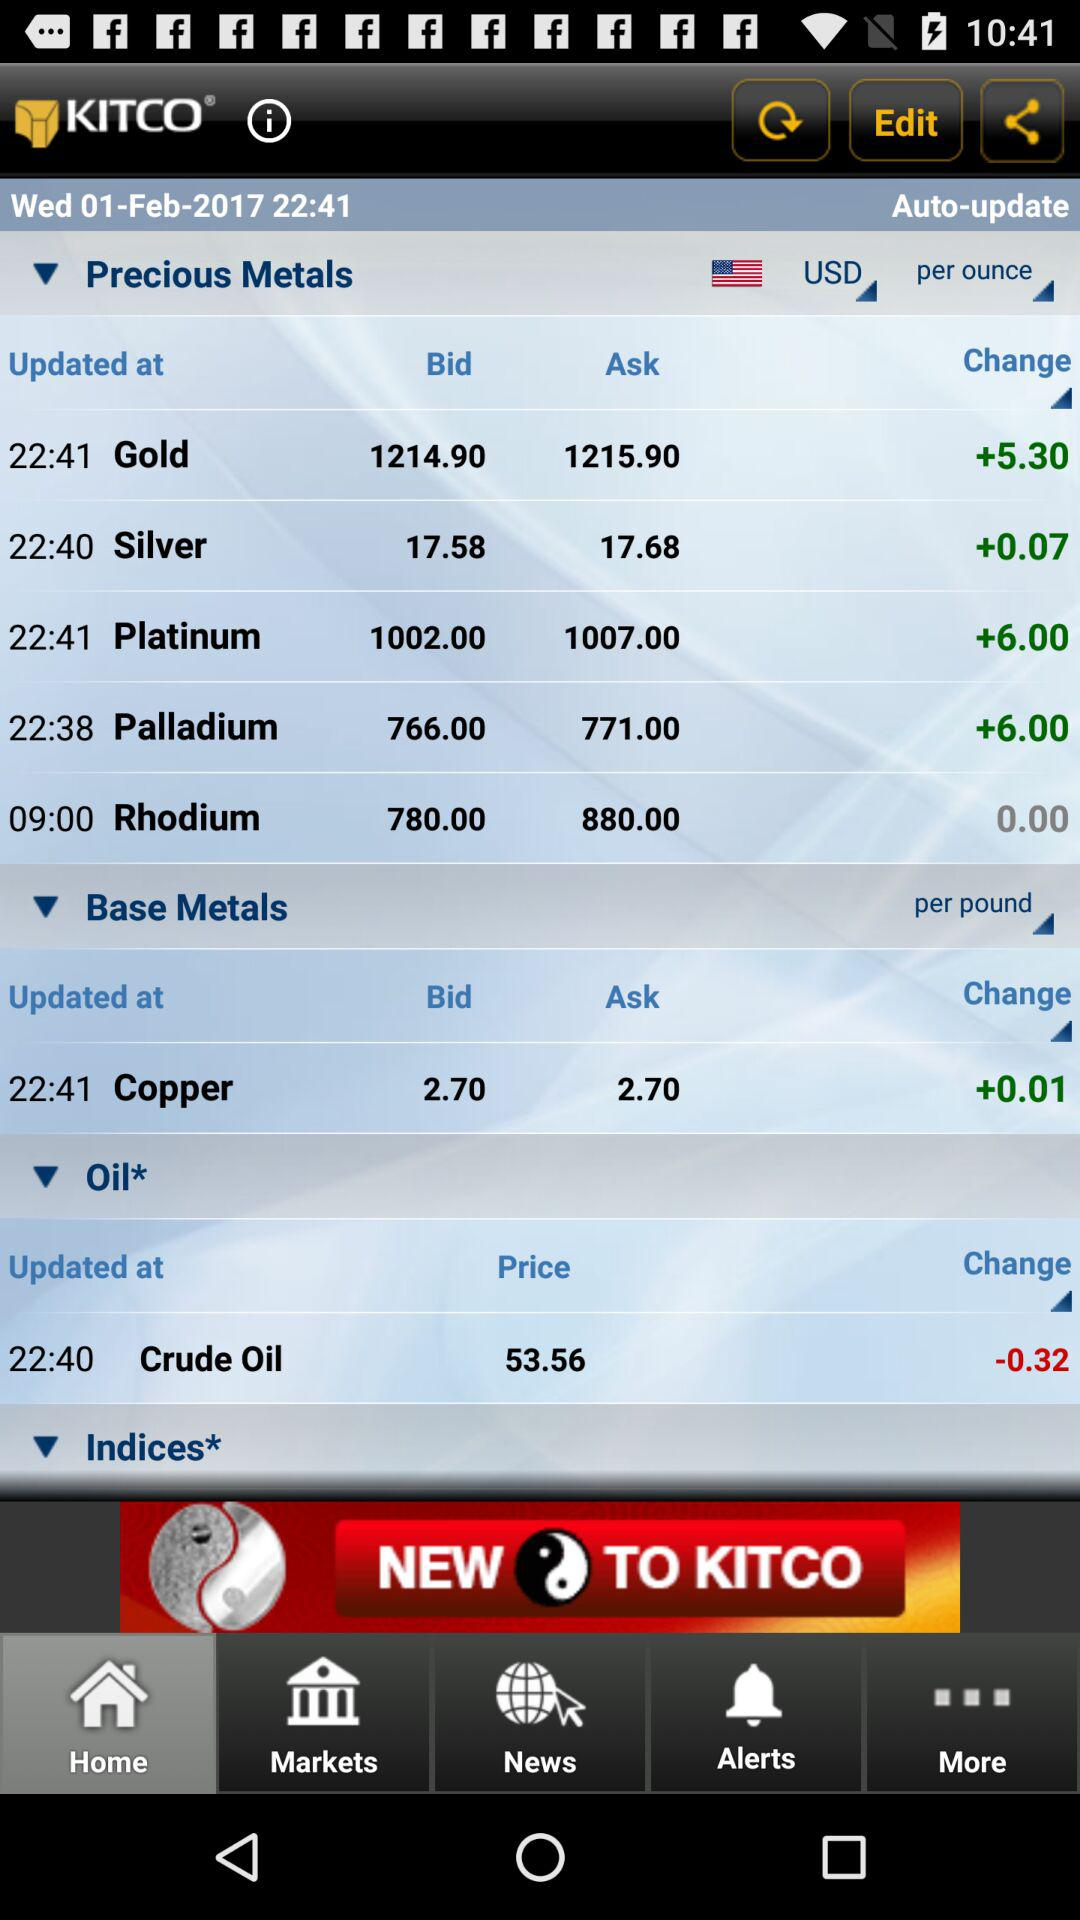On what date was "KITCO" last automatically updated? "KITCO" was last automatically updated on Wednesday, February 1, 2017. 